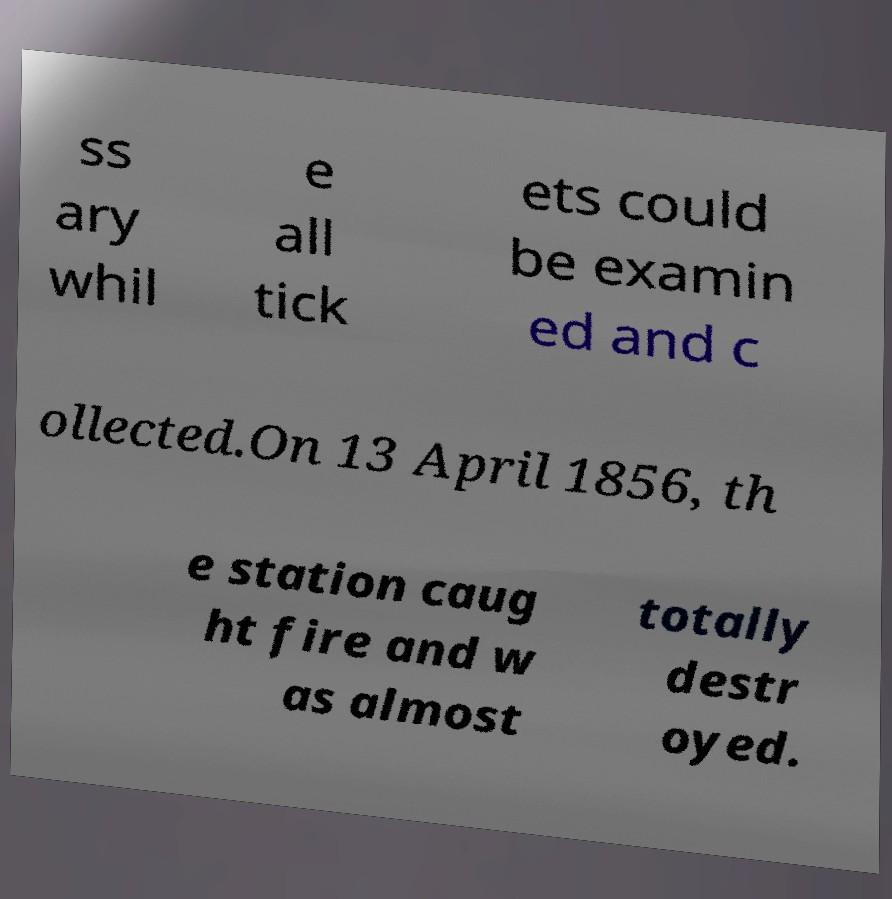For documentation purposes, I need the text within this image transcribed. Could you provide that? ss ary whil e all tick ets could be examin ed and c ollected.On 13 April 1856, th e station caug ht fire and w as almost totally destr oyed. 